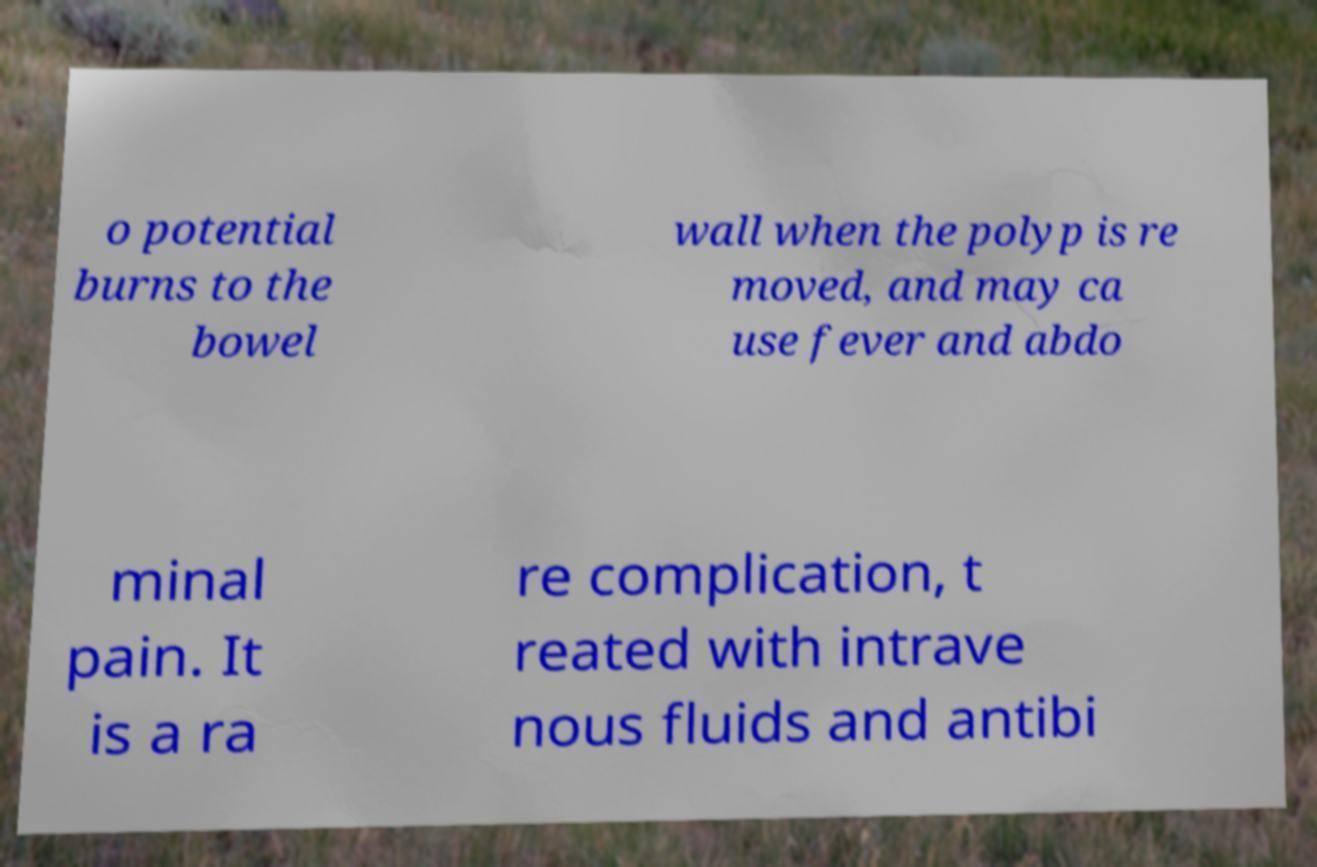Can you accurately transcribe the text from the provided image for me? o potential burns to the bowel wall when the polyp is re moved, and may ca use fever and abdo minal pain. It is a ra re complication, t reated with intrave nous fluids and antibi 